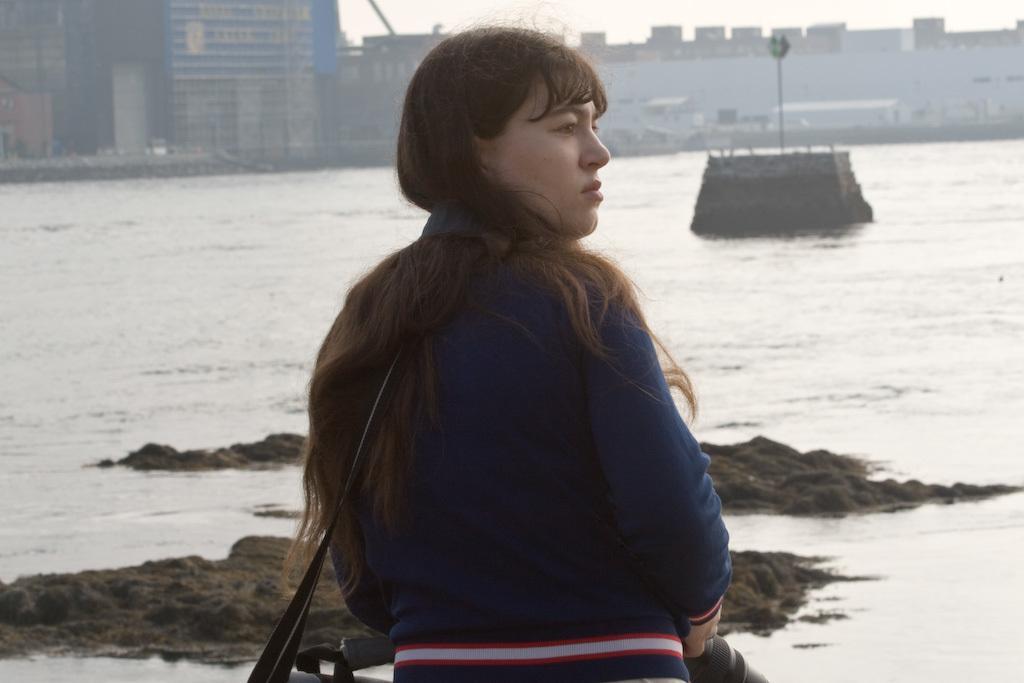In one or two sentences, can you explain what this image depicts? In front of the image there is a person holding the camera. In front of her there are rocks and water. In the center of the image there is a concrete structure. On top of it there is some object. In the background of the image there are buildings. 